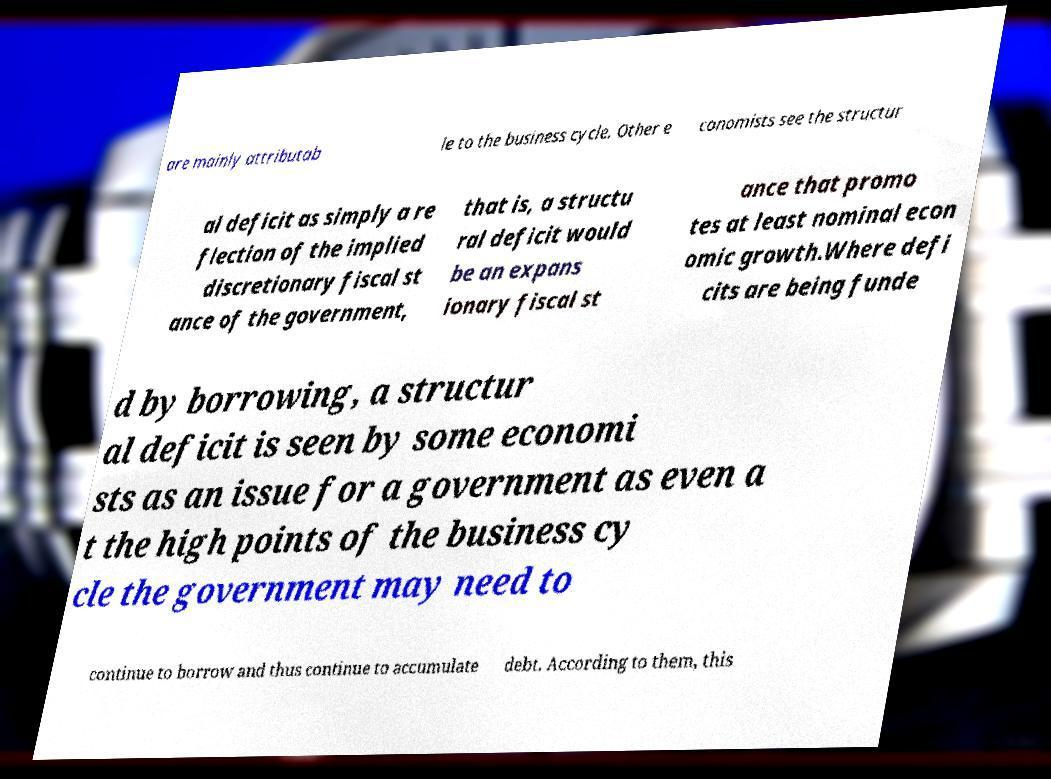I need the written content from this picture converted into text. Can you do that? are mainly attributab le to the business cycle. Other e conomists see the structur al deficit as simply a re flection of the implied discretionary fiscal st ance of the government, that is, a structu ral deficit would be an expans ionary fiscal st ance that promo tes at least nominal econ omic growth.Where defi cits are being funde d by borrowing, a structur al deficit is seen by some economi sts as an issue for a government as even a t the high points of the business cy cle the government may need to continue to borrow and thus continue to accumulate debt. According to them, this 